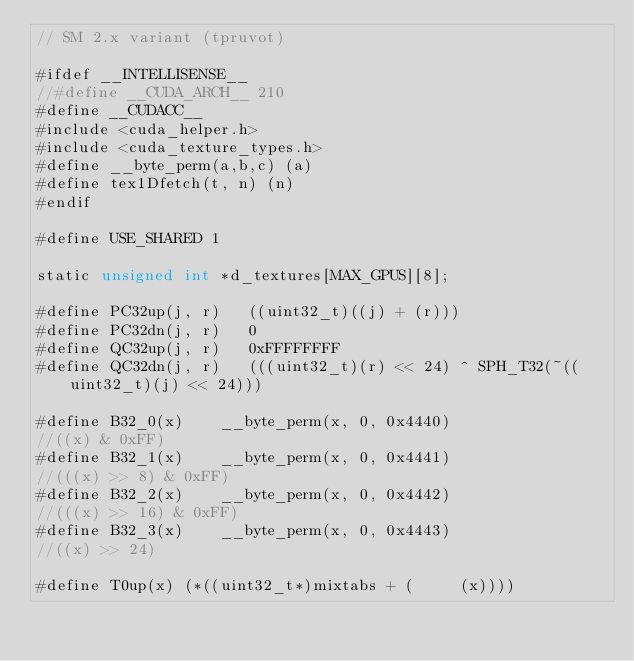<code> <loc_0><loc_0><loc_500><loc_500><_Cuda_>// SM 2.x variant (tpruvot)

#ifdef __INTELLISENSE__
//#define __CUDA_ARCH__ 210
#define __CUDACC__
#include <cuda_helper.h>
#include <cuda_texture_types.h>
#define __byte_perm(a,b,c) (a)
#define tex1Dfetch(t, n) (n)
#endif

#define USE_SHARED 1

static unsigned int *d_textures[MAX_GPUS][8];

#define PC32up(j, r)   ((uint32_t)((j) + (r)))
#define PC32dn(j, r)   0
#define QC32up(j, r)   0xFFFFFFFF
#define QC32dn(j, r)   (((uint32_t)(r) << 24) ^ SPH_T32(~((uint32_t)(j) << 24)))

#define B32_0(x)    __byte_perm(x, 0, 0x4440)
//((x) & 0xFF)
#define B32_1(x)    __byte_perm(x, 0, 0x4441)
//(((x) >> 8) & 0xFF)
#define B32_2(x)    __byte_perm(x, 0, 0x4442)
//(((x) >> 16) & 0xFF)
#define B32_3(x)    __byte_perm(x, 0, 0x4443)
//((x) >> 24)

#define T0up(x) (*((uint32_t*)mixtabs + (     (x))))</code> 